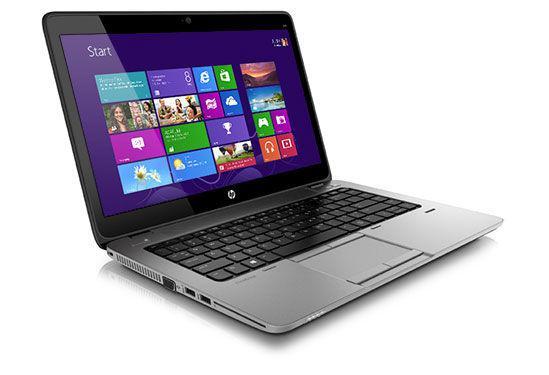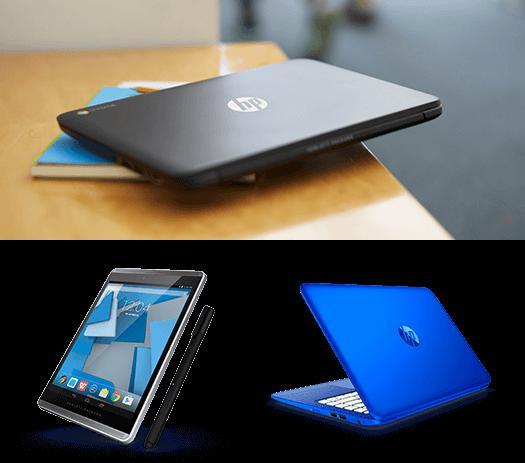The first image is the image on the left, the second image is the image on the right. Evaluate the accuracy of this statement regarding the images: "All laptops in the paired pictures have the same screen image.". Is it true? Answer yes or no. No. 